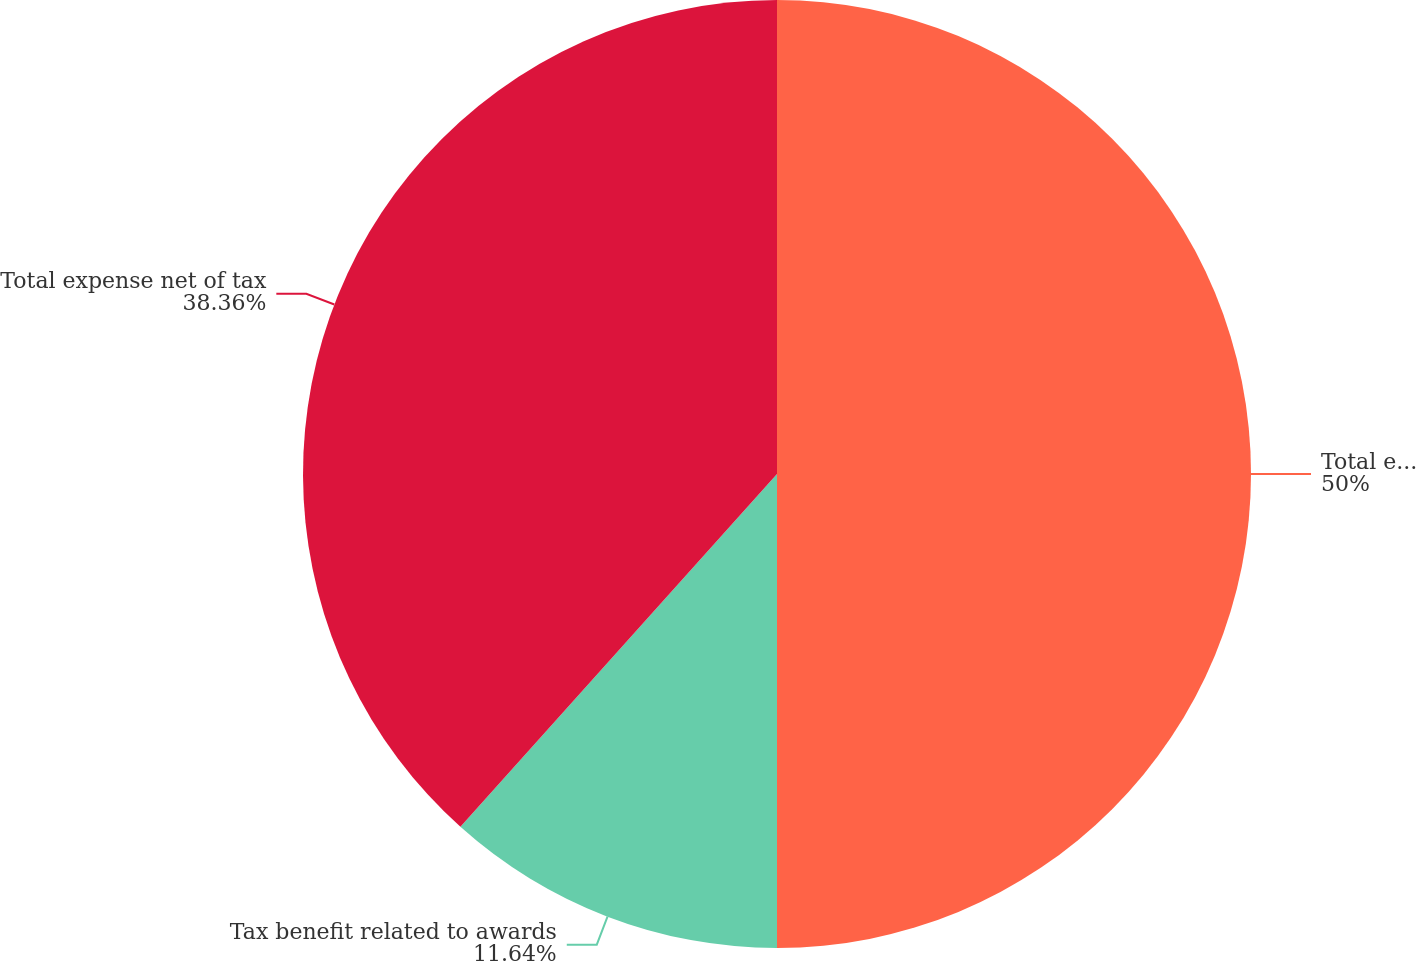Convert chart to OTSL. <chart><loc_0><loc_0><loc_500><loc_500><pie_chart><fcel>Total expense pre-tax<fcel>Tax benefit related to awards<fcel>Total expense net of tax<nl><fcel>50.0%<fcel>11.64%<fcel>38.36%<nl></chart> 